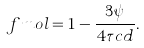<formula> <loc_0><loc_0><loc_500><loc_500>\ f m o l = 1 - \frac { 3 \psi } { 4 \tau c d } .</formula> 